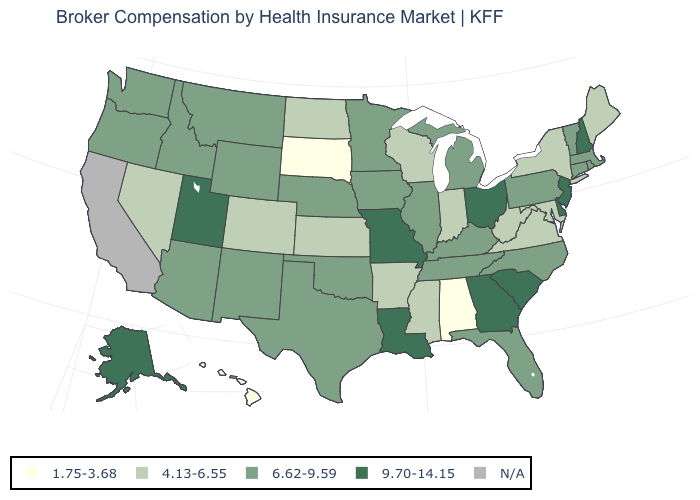What is the value of Pennsylvania?
Concise answer only. 6.62-9.59. What is the value of Arizona?
Be succinct. 6.62-9.59. Among the states that border North Carolina , does Georgia have the highest value?
Write a very short answer. Yes. Which states have the lowest value in the South?
Concise answer only. Alabama. Does South Dakota have the lowest value in the USA?
Answer briefly. Yes. Name the states that have a value in the range N/A?
Keep it brief. California. Which states have the highest value in the USA?
Write a very short answer. Alaska, Delaware, Georgia, Louisiana, Missouri, New Hampshire, New Jersey, Ohio, South Carolina, Utah. What is the value of Vermont?
Answer briefly. 6.62-9.59. Which states have the lowest value in the USA?
Concise answer only. Alabama, Hawaii, South Dakota. Among the states that border Arkansas , does Mississippi have the lowest value?
Concise answer only. Yes. Does Washington have the highest value in the West?
Short answer required. No. Which states have the lowest value in the USA?
Be succinct. Alabama, Hawaii, South Dakota. What is the highest value in the MidWest ?
Be succinct. 9.70-14.15. What is the highest value in the Northeast ?
Quick response, please. 9.70-14.15. Name the states that have a value in the range N/A?
Quick response, please. California. 